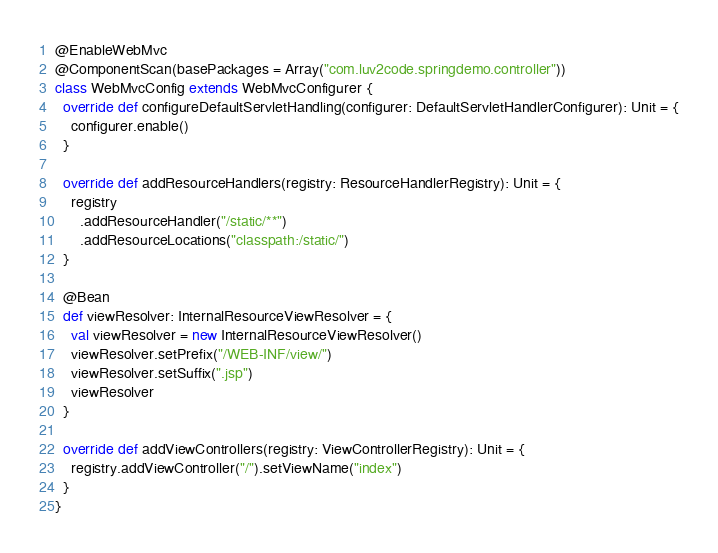<code> <loc_0><loc_0><loc_500><loc_500><_Scala_>@EnableWebMvc
@ComponentScan(basePackages = Array("com.luv2code.springdemo.controller"))
class WebMvcConfig extends WebMvcConfigurer {
  override def configureDefaultServletHandling(configurer: DefaultServletHandlerConfigurer): Unit = {
    configurer.enable()
  }

  override def addResourceHandlers(registry: ResourceHandlerRegistry): Unit = {
    registry
      .addResourceHandler("/static/**")
      .addResourceLocations("classpath:/static/")
  }

  @Bean
  def viewResolver: InternalResourceViewResolver = {
    val viewResolver = new InternalResourceViewResolver()
    viewResolver.setPrefix("/WEB-INF/view/")
    viewResolver.setSuffix(".jsp")
    viewResolver
  }

  override def addViewControllers(registry: ViewControllerRegistry): Unit = {
    registry.addViewController("/").setViewName("index")
  }
}
</code> 